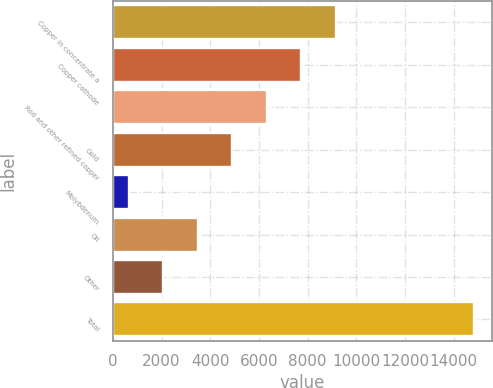<chart> <loc_0><loc_0><loc_500><loc_500><bar_chart><fcel>Copper in concentrate a<fcel>Copper cathode<fcel>Rod and other refined copper<fcel>Gold<fcel>Molybdenum<fcel>Oil<fcel>Other<fcel>Total<nl><fcel>9158.4<fcel>7740.5<fcel>6322.6<fcel>4904.7<fcel>651<fcel>3486.8<fcel>2068.9<fcel>14830<nl></chart> 